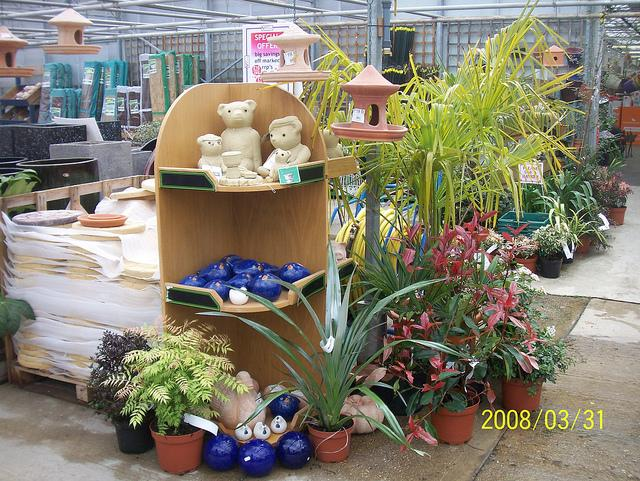What kind of animal is on the top shelf? bear 